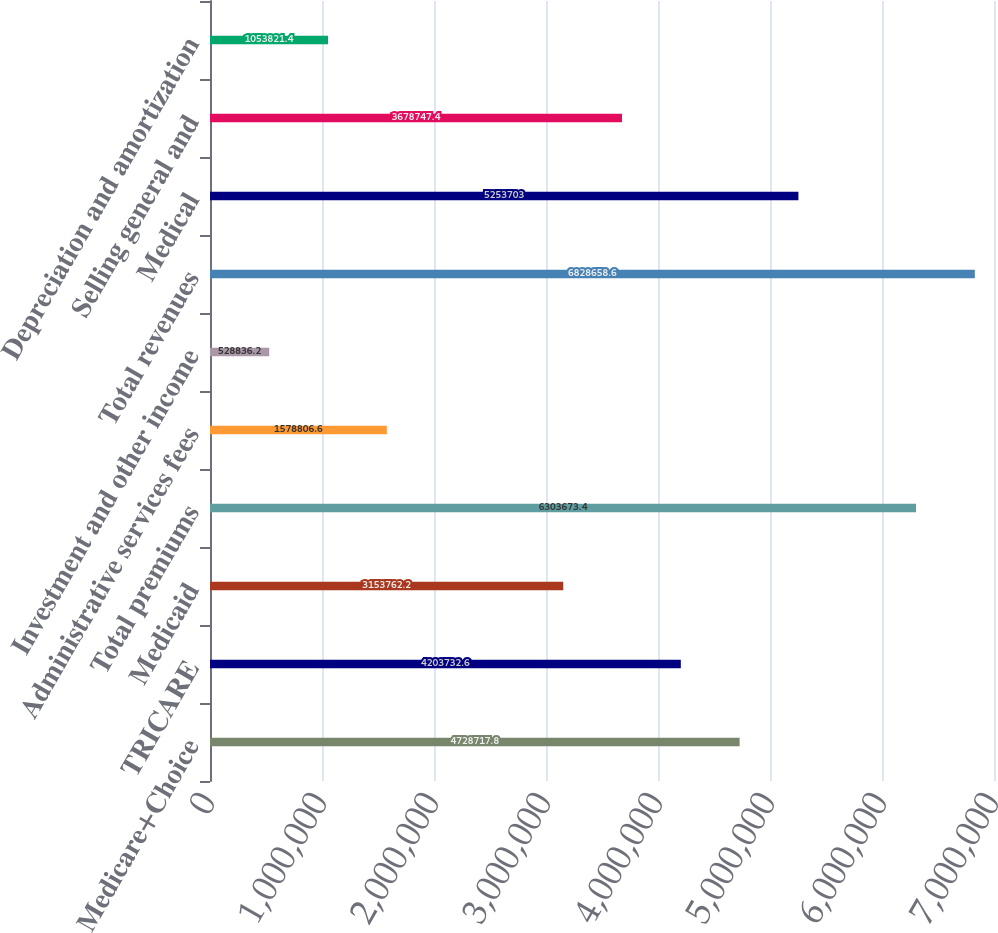Convert chart to OTSL. <chart><loc_0><loc_0><loc_500><loc_500><bar_chart><fcel>Medicare+Choice<fcel>TRICARE<fcel>Medicaid<fcel>Total premiums<fcel>Administrative services fees<fcel>Investment and other income<fcel>Total revenues<fcel>Medical<fcel>Selling general and<fcel>Depreciation and amortization<nl><fcel>4.72872e+06<fcel>4.20373e+06<fcel>3.15376e+06<fcel>6.30367e+06<fcel>1.57881e+06<fcel>528836<fcel>6.82866e+06<fcel>5.2537e+06<fcel>3.67875e+06<fcel>1.05382e+06<nl></chart> 